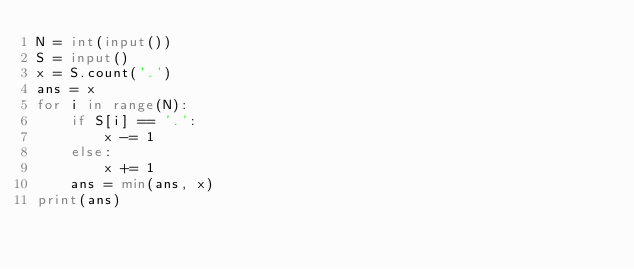Convert code to text. <code><loc_0><loc_0><loc_500><loc_500><_Python_>N = int(input())
S = input()
x = S.count('.')
ans = x
for i in range(N):
	if S[i] == '.':
		x -= 1
	else:
		x += 1
	ans = min(ans, x)
print(ans)</code> 